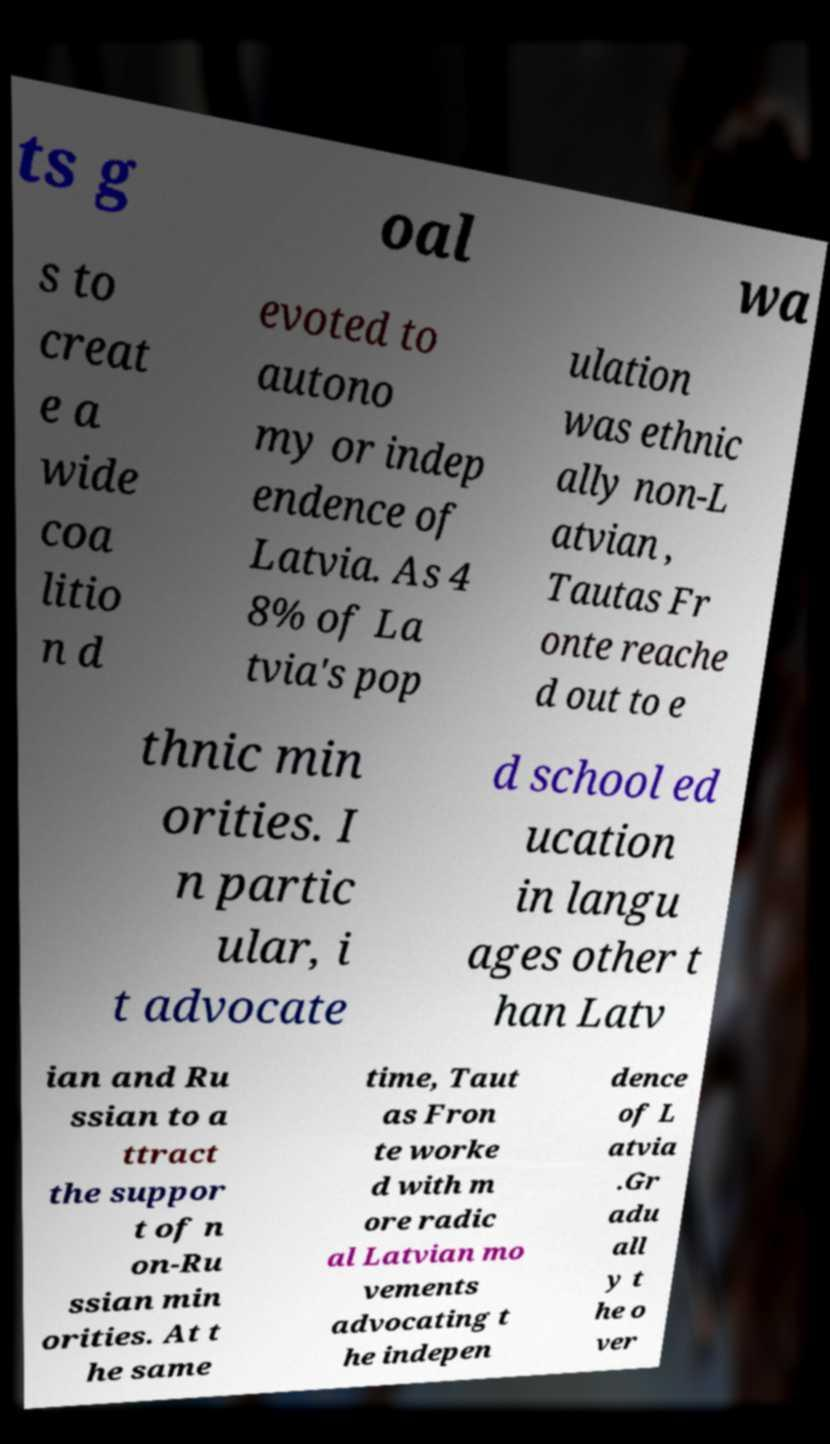Could you extract and type out the text from this image? ts g oal wa s to creat e a wide coa litio n d evoted to autono my or indep endence of Latvia. As 4 8% of La tvia's pop ulation was ethnic ally non-L atvian , Tautas Fr onte reache d out to e thnic min orities. I n partic ular, i t advocate d school ed ucation in langu ages other t han Latv ian and Ru ssian to a ttract the suppor t of n on-Ru ssian min orities. At t he same time, Taut as Fron te worke d with m ore radic al Latvian mo vements advocating t he indepen dence of L atvia .Gr adu all y t he o ver 